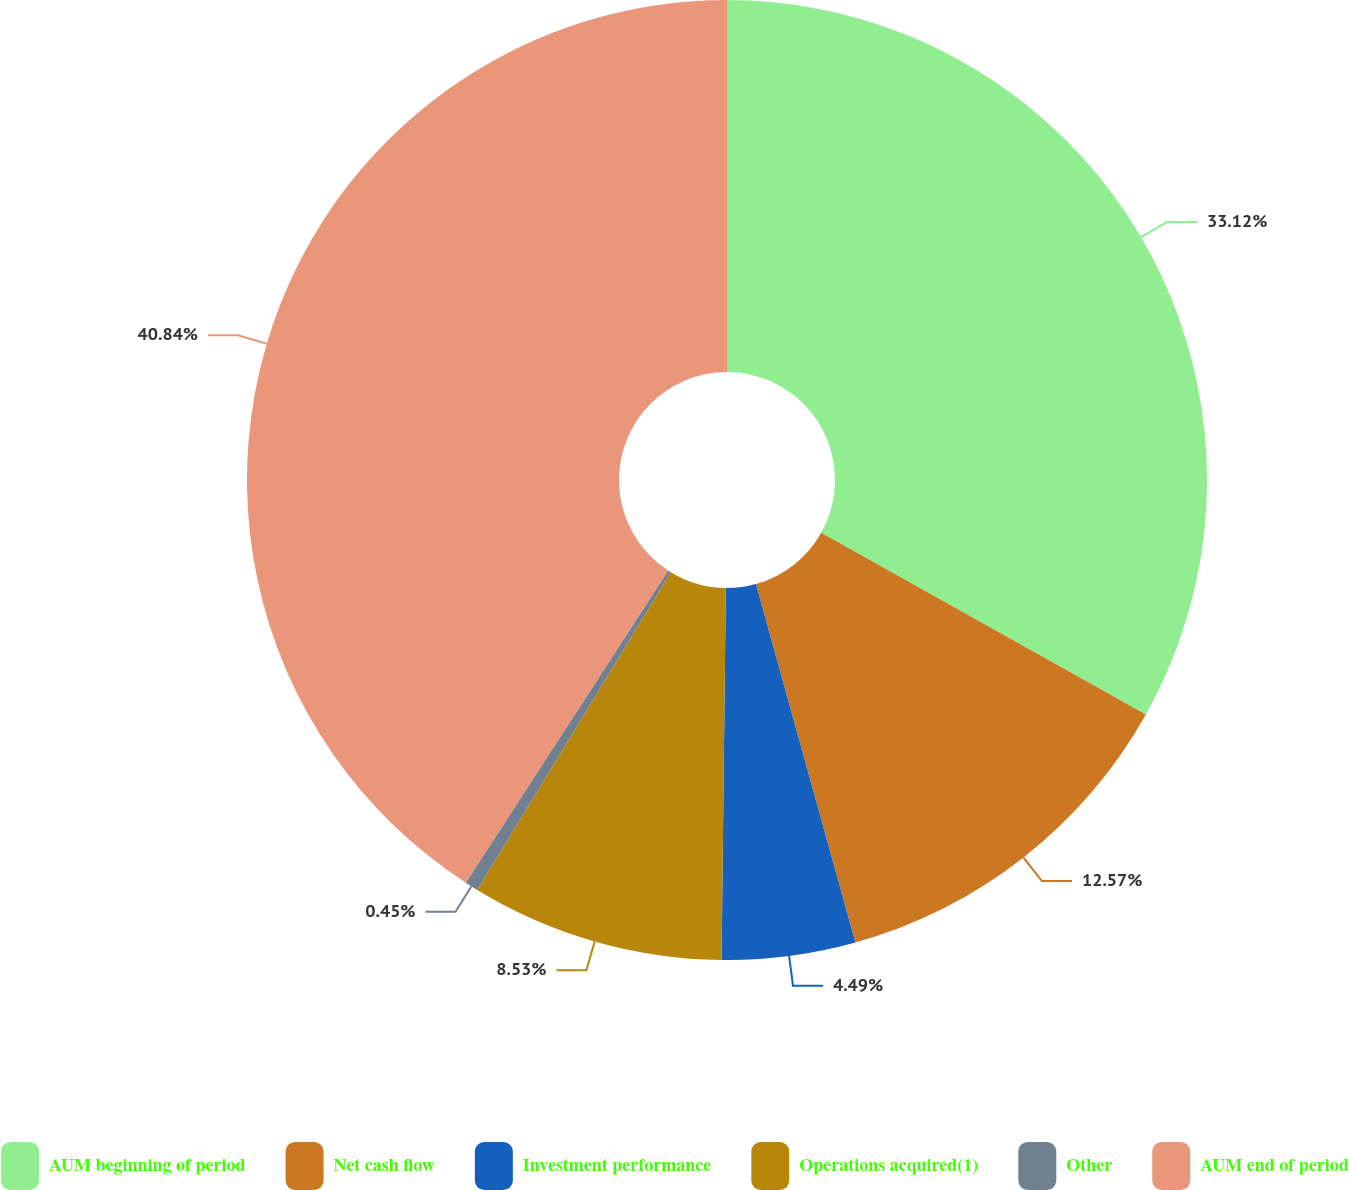<chart> <loc_0><loc_0><loc_500><loc_500><pie_chart><fcel>AUM beginning of period<fcel>Net cash flow<fcel>Investment performance<fcel>Operations acquired(1)<fcel>Other<fcel>AUM end of period<nl><fcel>33.12%<fcel>12.57%<fcel>4.49%<fcel>8.53%<fcel>0.45%<fcel>40.84%<nl></chart> 